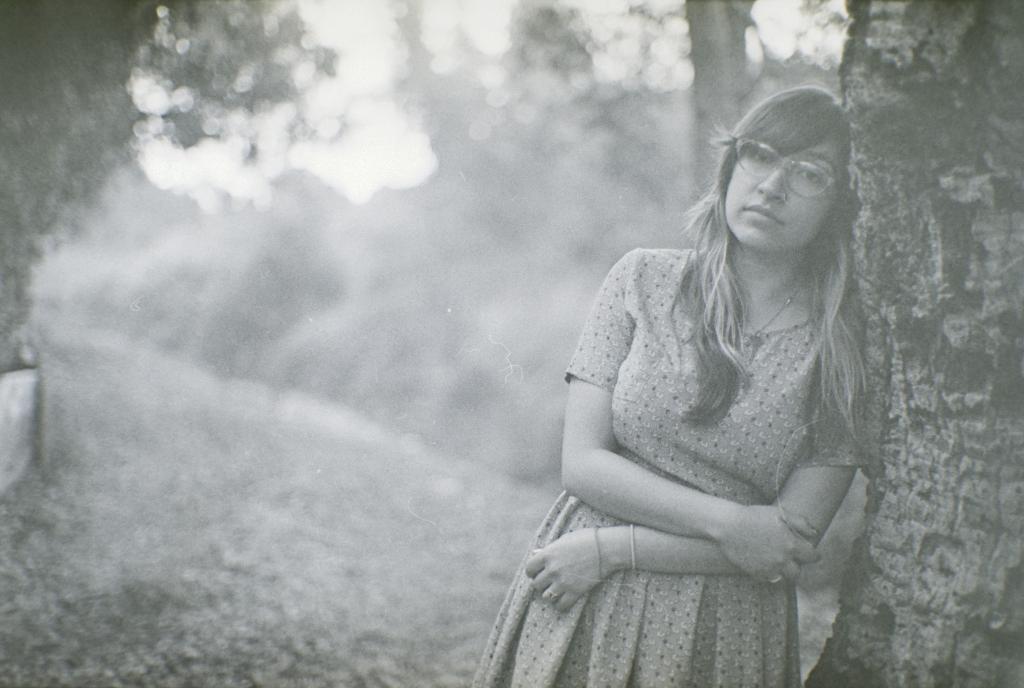What is the color scheme of the image? The image is black and white. What is the woman in the image doing? The woman is standing on the ground and leaning against a tree. What can be seen in the background of the image? There are trees and the sky visible in the background of the image. What type of hill can be seen in the background of the image? There is no hill present in the image; it features a woman standing near a tree with trees and the sky visible in the background. 